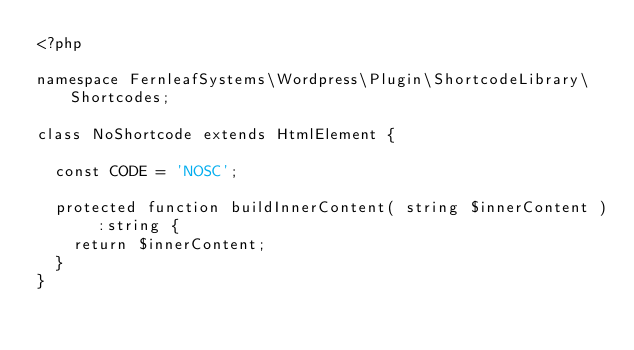Convert code to text. <code><loc_0><loc_0><loc_500><loc_500><_PHP_><?php

namespace FernleafSystems\Wordpress\Plugin\ShortcodeLibrary\Shortcodes;

class NoShortcode extends HtmlElement {

	const CODE = 'NOSC';

	protected function buildInnerContent( string $innerContent ) :string {
		return $innerContent;
	}
}
</code> 